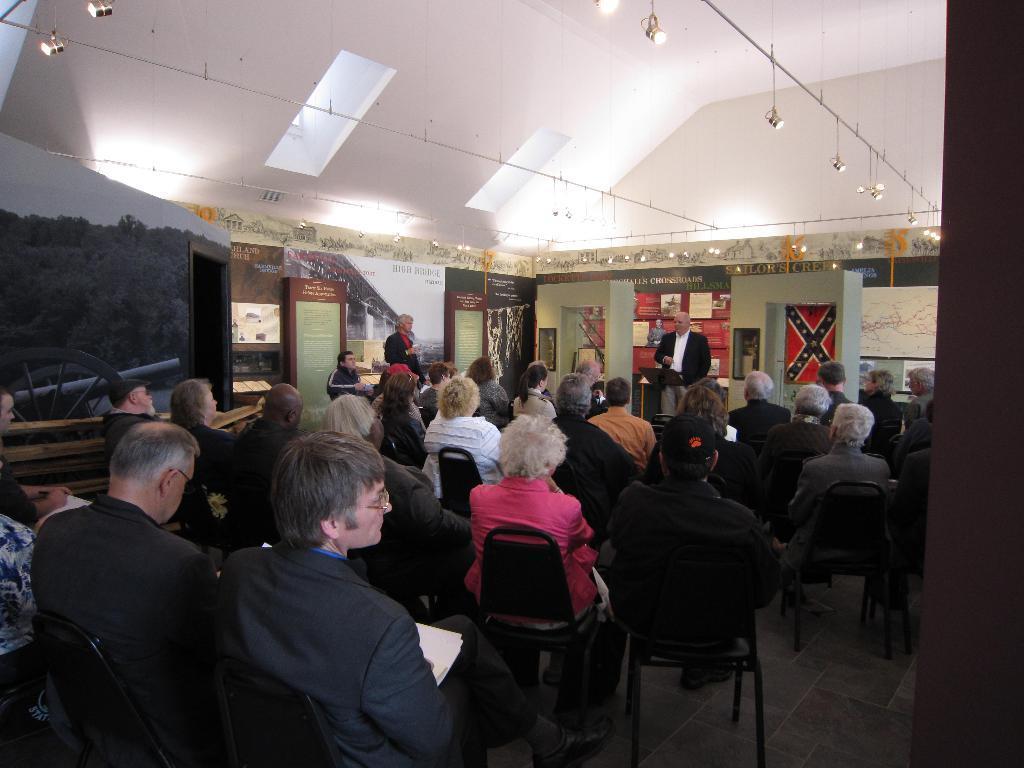In one or two sentences, can you explain what this image depicts? In this image we can see the people sitting on the chairs which are on the floor. We can also see the boards, posters, wall, rods and also the lights. We can see the two persons standing. We can also see the map and also the ceiling. 